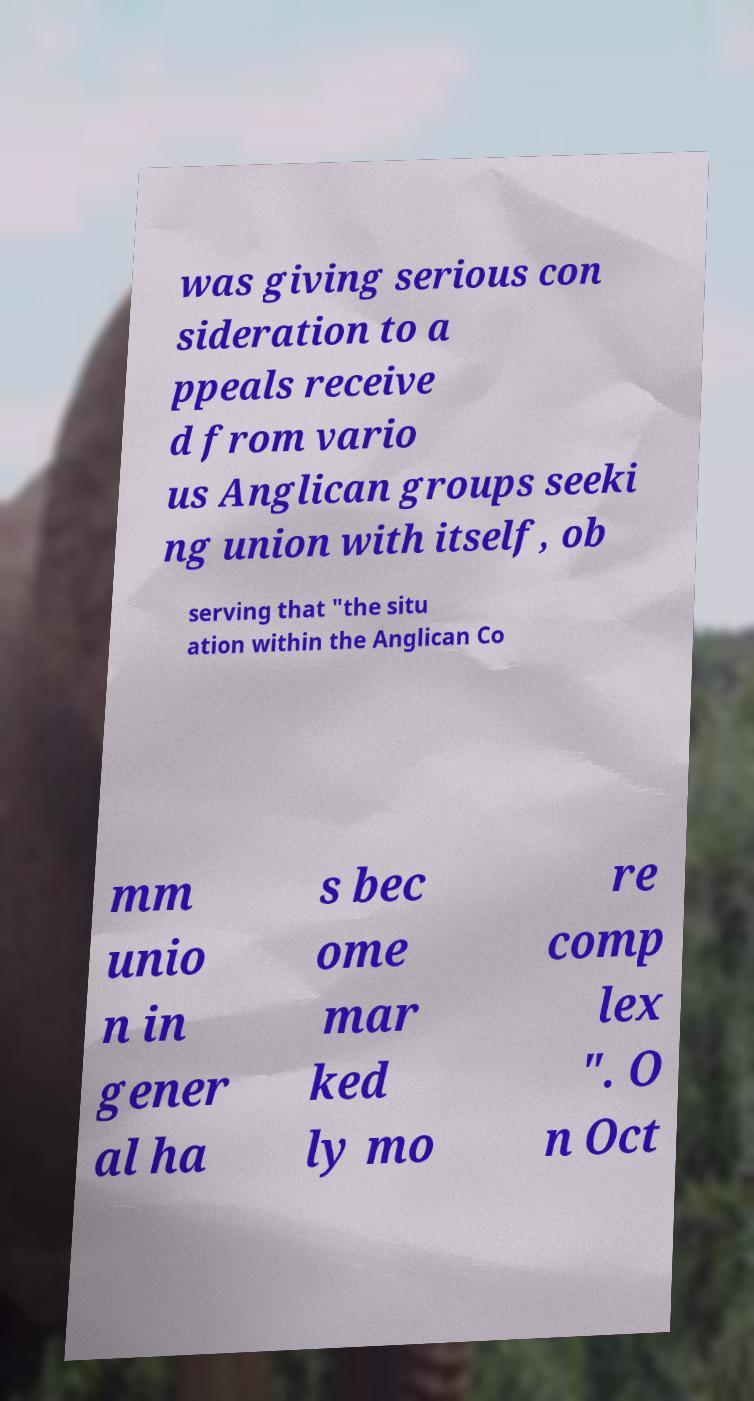I need the written content from this picture converted into text. Can you do that? was giving serious con sideration to a ppeals receive d from vario us Anglican groups seeki ng union with itself, ob serving that "the situ ation within the Anglican Co mm unio n in gener al ha s bec ome mar ked ly mo re comp lex ". O n Oct 